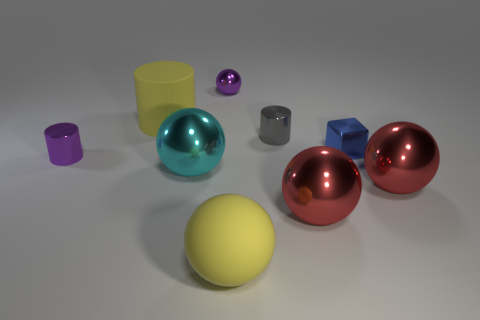The small thing that is to the right of the large matte sphere and to the left of the small blue thing is made of what material?
Offer a very short reply. Metal. How many big yellow rubber things have the same shape as the tiny blue object?
Offer a very short reply. 0. There is a yellow matte object in front of the small cylinder that is to the right of the large cyan sphere; how big is it?
Make the answer very short. Large. Does the matte object that is in front of the large cyan metallic ball have the same color as the tiny shiny cylinder that is left of the purple sphere?
Offer a terse response. No. What number of small cubes are left of the big rubber object that is in front of the large matte thing that is behind the blue metallic block?
Offer a very short reply. 0. How many things are both left of the large rubber ball and to the right of the tiny metal block?
Offer a very short reply. 0. Are there more large metallic objects that are behind the purple cylinder than big rubber spheres?
Provide a succinct answer. No. How many rubber objects are the same size as the cyan sphere?
Keep it short and to the point. 2. There is a matte thing that is the same color as the big matte cylinder; what is its size?
Your answer should be compact. Large. How many tiny things are either yellow matte things or gray balls?
Your answer should be very brief. 0. 